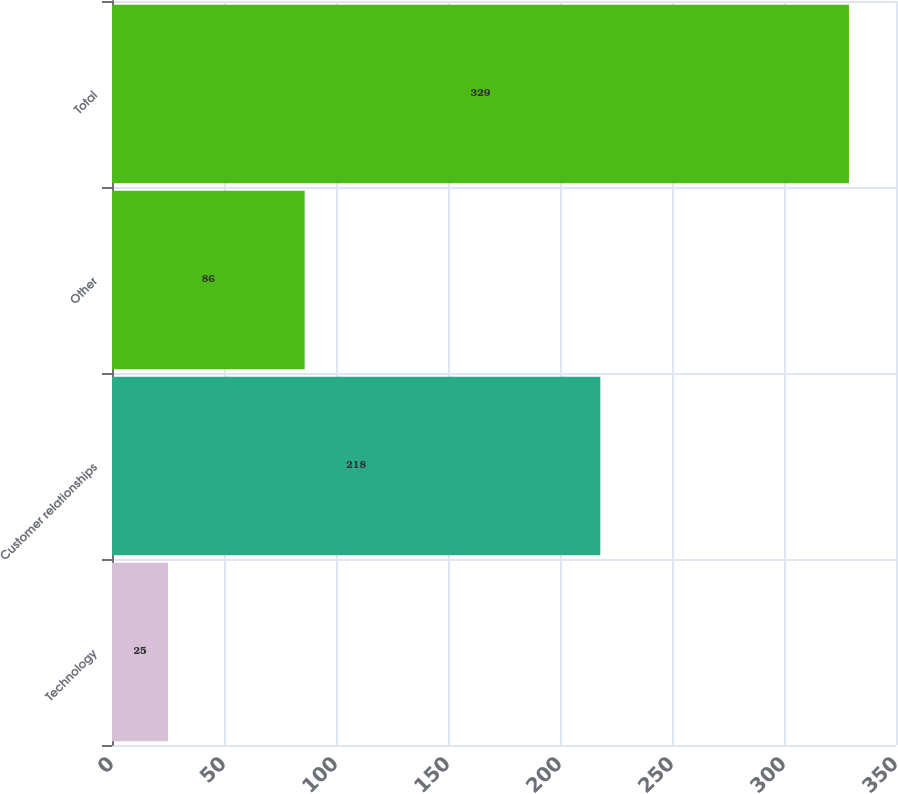Convert chart. <chart><loc_0><loc_0><loc_500><loc_500><bar_chart><fcel>Technology<fcel>Customer relationships<fcel>Other<fcel>Total<nl><fcel>25<fcel>218<fcel>86<fcel>329<nl></chart> 